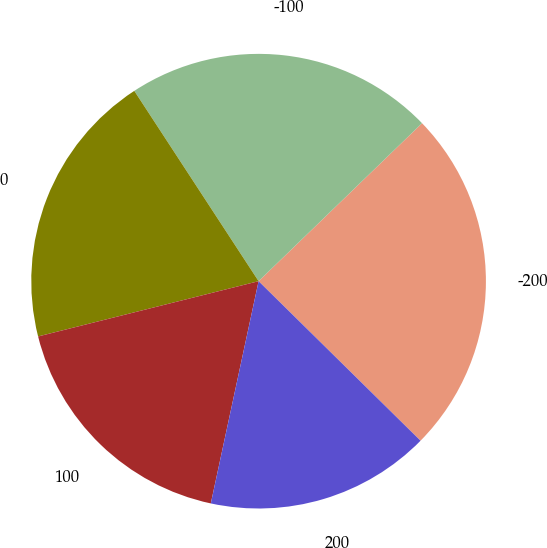<chart> <loc_0><loc_0><loc_500><loc_500><pie_chart><fcel>-200<fcel>-100<fcel>0<fcel>100<fcel>200<nl><fcel>24.61%<fcel>21.98%<fcel>19.7%<fcel>17.72%<fcel>15.99%<nl></chart> 